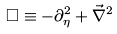Convert formula to latex. <formula><loc_0><loc_0><loc_500><loc_500>\Box \equiv - \partial _ { \eta } ^ { 2 } + \vec { \nabla } ^ { 2 }</formula> 